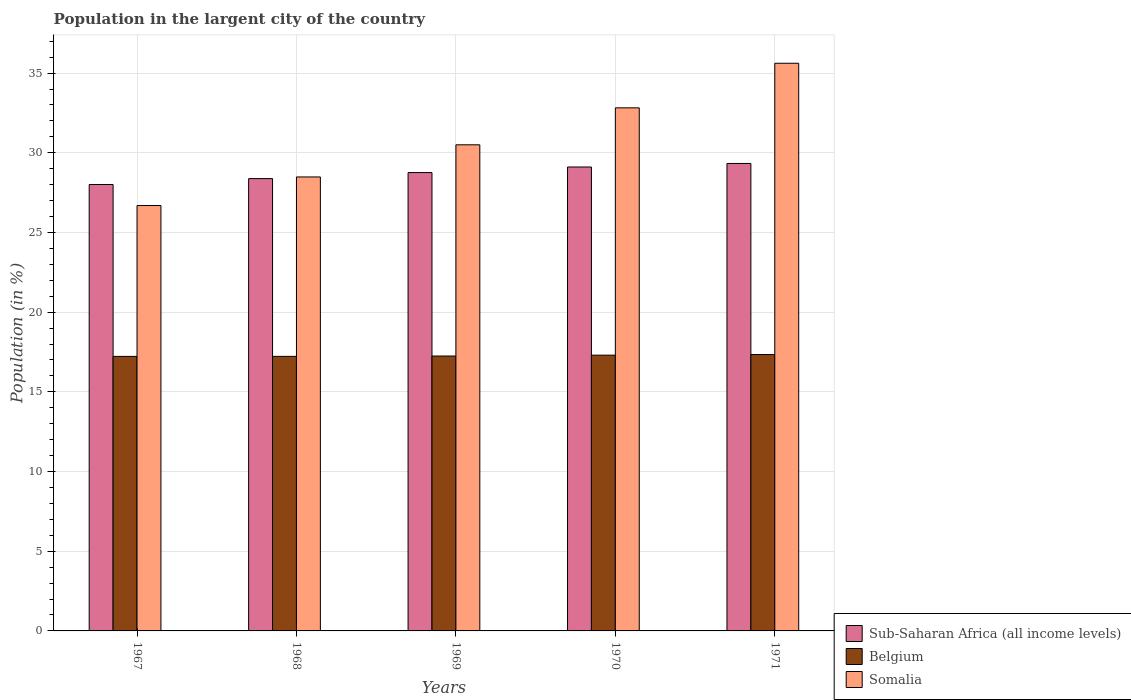How many groups of bars are there?
Offer a very short reply. 5. Are the number of bars on each tick of the X-axis equal?
Your response must be concise. Yes. What is the label of the 2nd group of bars from the left?
Your answer should be compact. 1968. In how many cases, is the number of bars for a given year not equal to the number of legend labels?
Offer a terse response. 0. What is the percentage of population in the largent city in Sub-Saharan Africa (all income levels) in 1970?
Your answer should be very brief. 29.11. Across all years, what is the maximum percentage of population in the largent city in Somalia?
Your answer should be very brief. 35.62. Across all years, what is the minimum percentage of population in the largent city in Sub-Saharan Africa (all income levels)?
Your answer should be compact. 28.01. In which year was the percentage of population in the largent city in Belgium minimum?
Provide a succinct answer. 1967. What is the total percentage of population in the largent city in Somalia in the graph?
Make the answer very short. 154.11. What is the difference between the percentage of population in the largent city in Sub-Saharan Africa (all income levels) in 1970 and that in 1971?
Provide a succinct answer. -0.22. What is the difference between the percentage of population in the largent city in Somalia in 1968 and the percentage of population in the largent city in Belgium in 1971?
Provide a short and direct response. 11.14. What is the average percentage of population in the largent city in Sub-Saharan Africa (all income levels) per year?
Give a very brief answer. 28.72. In the year 1969, what is the difference between the percentage of population in the largent city in Sub-Saharan Africa (all income levels) and percentage of population in the largent city in Belgium?
Ensure brevity in your answer.  11.51. What is the ratio of the percentage of population in the largent city in Somalia in 1968 to that in 1970?
Your answer should be very brief. 0.87. Is the percentage of population in the largent city in Sub-Saharan Africa (all income levels) in 1968 less than that in 1969?
Make the answer very short. Yes. What is the difference between the highest and the second highest percentage of population in the largent city in Somalia?
Provide a succinct answer. 2.8. What is the difference between the highest and the lowest percentage of population in the largent city in Belgium?
Your answer should be compact. 0.12. What does the 3rd bar from the left in 1967 represents?
Provide a short and direct response. Somalia. What does the 3rd bar from the right in 1967 represents?
Give a very brief answer. Sub-Saharan Africa (all income levels). Are all the bars in the graph horizontal?
Make the answer very short. No. How many years are there in the graph?
Your response must be concise. 5. What is the difference between two consecutive major ticks on the Y-axis?
Your response must be concise. 5. Are the values on the major ticks of Y-axis written in scientific E-notation?
Ensure brevity in your answer.  No. Does the graph contain any zero values?
Your answer should be compact. No. How are the legend labels stacked?
Keep it short and to the point. Vertical. What is the title of the graph?
Provide a short and direct response. Population in the largent city of the country. Does "Fiji" appear as one of the legend labels in the graph?
Give a very brief answer. No. What is the label or title of the Y-axis?
Give a very brief answer. Population (in %). What is the Population (in %) in Sub-Saharan Africa (all income levels) in 1967?
Keep it short and to the point. 28.01. What is the Population (in %) in Belgium in 1967?
Give a very brief answer. 17.22. What is the Population (in %) in Somalia in 1967?
Ensure brevity in your answer.  26.69. What is the Population (in %) in Sub-Saharan Africa (all income levels) in 1968?
Your answer should be very brief. 28.38. What is the Population (in %) of Belgium in 1968?
Offer a very short reply. 17.23. What is the Population (in %) in Somalia in 1968?
Give a very brief answer. 28.48. What is the Population (in %) of Sub-Saharan Africa (all income levels) in 1969?
Offer a very short reply. 28.76. What is the Population (in %) of Belgium in 1969?
Make the answer very short. 17.25. What is the Population (in %) in Somalia in 1969?
Offer a very short reply. 30.5. What is the Population (in %) in Sub-Saharan Africa (all income levels) in 1970?
Make the answer very short. 29.11. What is the Population (in %) in Belgium in 1970?
Your response must be concise. 17.3. What is the Population (in %) in Somalia in 1970?
Offer a terse response. 32.82. What is the Population (in %) of Sub-Saharan Africa (all income levels) in 1971?
Offer a terse response. 29.33. What is the Population (in %) in Belgium in 1971?
Provide a succinct answer. 17.34. What is the Population (in %) of Somalia in 1971?
Ensure brevity in your answer.  35.62. Across all years, what is the maximum Population (in %) of Sub-Saharan Africa (all income levels)?
Provide a short and direct response. 29.33. Across all years, what is the maximum Population (in %) of Belgium?
Your answer should be very brief. 17.34. Across all years, what is the maximum Population (in %) of Somalia?
Give a very brief answer. 35.62. Across all years, what is the minimum Population (in %) in Sub-Saharan Africa (all income levels)?
Ensure brevity in your answer.  28.01. Across all years, what is the minimum Population (in %) of Belgium?
Your answer should be very brief. 17.22. Across all years, what is the minimum Population (in %) of Somalia?
Keep it short and to the point. 26.69. What is the total Population (in %) of Sub-Saharan Africa (all income levels) in the graph?
Make the answer very short. 143.58. What is the total Population (in %) in Belgium in the graph?
Provide a succinct answer. 86.34. What is the total Population (in %) in Somalia in the graph?
Your answer should be compact. 154.11. What is the difference between the Population (in %) of Sub-Saharan Africa (all income levels) in 1967 and that in 1968?
Give a very brief answer. -0.37. What is the difference between the Population (in %) in Belgium in 1967 and that in 1968?
Offer a very short reply. -0. What is the difference between the Population (in %) in Somalia in 1967 and that in 1968?
Offer a terse response. -1.79. What is the difference between the Population (in %) of Sub-Saharan Africa (all income levels) in 1967 and that in 1969?
Your answer should be compact. -0.75. What is the difference between the Population (in %) of Belgium in 1967 and that in 1969?
Offer a very short reply. -0.02. What is the difference between the Population (in %) in Somalia in 1967 and that in 1969?
Provide a succinct answer. -3.81. What is the difference between the Population (in %) in Sub-Saharan Africa (all income levels) in 1967 and that in 1970?
Offer a terse response. -1.1. What is the difference between the Population (in %) in Belgium in 1967 and that in 1970?
Keep it short and to the point. -0.08. What is the difference between the Population (in %) in Somalia in 1967 and that in 1970?
Ensure brevity in your answer.  -6.13. What is the difference between the Population (in %) in Sub-Saharan Africa (all income levels) in 1967 and that in 1971?
Provide a short and direct response. -1.32. What is the difference between the Population (in %) of Belgium in 1967 and that in 1971?
Offer a very short reply. -0.12. What is the difference between the Population (in %) in Somalia in 1967 and that in 1971?
Provide a short and direct response. -8.93. What is the difference between the Population (in %) in Sub-Saharan Africa (all income levels) in 1968 and that in 1969?
Offer a very short reply. -0.38. What is the difference between the Population (in %) in Belgium in 1968 and that in 1969?
Make the answer very short. -0.02. What is the difference between the Population (in %) in Somalia in 1968 and that in 1969?
Your response must be concise. -2.02. What is the difference between the Population (in %) of Sub-Saharan Africa (all income levels) in 1968 and that in 1970?
Your response must be concise. -0.73. What is the difference between the Population (in %) of Belgium in 1968 and that in 1970?
Your response must be concise. -0.07. What is the difference between the Population (in %) in Somalia in 1968 and that in 1970?
Make the answer very short. -4.34. What is the difference between the Population (in %) of Sub-Saharan Africa (all income levels) in 1968 and that in 1971?
Give a very brief answer. -0.95. What is the difference between the Population (in %) of Belgium in 1968 and that in 1971?
Make the answer very short. -0.11. What is the difference between the Population (in %) of Somalia in 1968 and that in 1971?
Offer a very short reply. -7.13. What is the difference between the Population (in %) of Sub-Saharan Africa (all income levels) in 1969 and that in 1970?
Your answer should be compact. -0.35. What is the difference between the Population (in %) in Belgium in 1969 and that in 1970?
Offer a terse response. -0.05. What is the difference between the Population (in %) in Somalia in 1969 and that in 1970?
Your response must be concise. -2.32. What is the difference between the Population (in %) of Sub-Saharan Africa (all income levels) in 1969 and that in 1971?
Make the answer very short. -0.57. What is the difference between the Population (in %) in Belgium in 1969 and that in 1971?
Make the answer very short. -0.09. What is the difference between the Population (in %) in Somalia in 1969 and that in 1971?
Your answer should be very brief. -5.12. What is the difference between the Population (in %) of Sub-Saharan Africa (all income levels) in 1970 and that in 1971?
Provide a short and direct response. -0.22. What is the difference between the Population (in %) in Belgium in 1970 and that in 1971?
Provide a succinct answer. -0.04. What is the difference between the Population (in %) in Somalia in 1970 and that in 1971?
Give a very brief answer. -2.8. What is the difference between the Population (in %) in Sub-Saharan Africa (all income levels) in 1967 and the Population (in %) in Belgium in 1968?
Offer a terse response. 10.78. What is the difference between the Population (in %) in Sub-Saharan Africa (all income levels) in 1967 and the Population (in %) in Somalia in 1968?
Provide a short and direct response. -0.47. What is the difference between the Population (in %) in Belgium in 1967 and the Population (in %) in Somalia in 1968?
Give a very brief answer. -11.26. What is the difference between the Population (in %) in Sub-Saharan Africa (all income levels) in 1967 and the Population (in %) in Belgium in 1969?
Your response must be concise. 10.76. What is the difference between the Population (in %) in Sub-Saharan Africa (all income levels) in 1967 and the Population (in %) in Somalia in 1969?
Provide a succinct answer. -2.49. What is the difference between the Population (in %) of Belgium in 1967 and the Population (in %) of Somalia in 1969?
Provide a short and direct response. -13.27. What is the difference between the Population (in %) in Sub-Saharan Africa (all income levels) in 1967 and the Population (in %) in Belgium in 1970?
Ensure brevity in your answer.  10.71. What is the difference between the Population (in %) of Sub-Saharan Africa (all income levels) in 1967 and the Population (in %) of Somalia in 1970?
Give a very brief answer. -4.81. What is the difference between the Population (in %) of Belgium in 1967 and the Population (in %) of Somalia in 1970?
Offer a terse response. -15.59. What is the difference between the Population (in %) of Sub-Saharan Africa (all income levels) in 1967 and the Population (in %) of Belgium in 1971?
Offer a very short reply. 10.67. What is the difference between the Population (in %) in Sub-Saharan Africa (all income levels) in 1967 and the Population (in %) in Somalia in 1971?
Your answer should be compact. -7.61. What is the difference between the Population (in %) in Belgium in 1967 and the Population (in %) in Somalia in 1971?
Keep it short and to the point. -18.39. What is the difference between the Population (in %) in Sub-Saharan Africa (all income levels) in 1968 and the Population (in %) in Belgium in 1969?
Offer a terse response. 11.13. What is the difference between the Population (in %) of Sub-Saharan Africa (all income levels) in 1968 and the Population (in %) of Somalia in 1969?
Your response must be concise. -2.12. What is the difference between the Population (in %) in Belgium in 1968 and the Population (in %) in Somalia in 1969?
Make the answer very short. -13.27. What is the difference between the Population (in %) in Sub-Saharan Africa (all income levels) in 1968 and the Population (in %) in Belgium in 1970?
Keep it short and to the point. 11.08. What is the difference between the Population (in %) in Sub-Saharan Africa (all income levels) in 1968 and the Population (in %) in Somalia in 1970?
Ensure brevity in your answer.  -4.44. What is the difference between the Population (in %) of Belgium in 1968 and the Population (in %) of Somalia in 1970?
Provide a short and direct response. -15.59. What is the difference between the Population (in %) of Sub-Saharan Africa (all income levels) in 1968 and the Population (in %) of Belgium in 1971?
Make the answer very short. 11.04. What is the difference between the Population (in %) of Sub-Saharan Africa (all income levels) in 1968 and the Population (in %) of Somalia in 1971?
Keep it short and to the point. -7.24. What is the difference between the Population (in %) in Belgium in 1968 and the Population (in %) in Somalia in 1971?
Give a very brief answer. -18.39. What is the difference between the Population (in %) in Sub-Saharan Africa (all income levels) in 1969 and the Population (in %) in Belgium in 1970?
Ensure brevity in your answer.  11.46. What is the difference between the Population (in %) of Sub-Saharan Africa (all income levels) in 1969 and the Population (in %) of Somalia in 1970?
Offer a very short reply. -4.06. What is the difference between the Population (in %) in Belgium in 1969 and the Population (in %) in Somalia in 1970?
Offer a very short reply. -15.57. What is the difference between the Population (in %) in Sub-Saharan Africa (all income levels) in 1969 and the Population (in %) in Belgium in 1971?
Offer a very short reply. 11.42. What is the difference between the Population (in %) in Sub-Saharan Africa (all income levels) in 1969 and the Population (in %) in Somalia in 1971?
Your answer should be very brief. -6.86. What is the difference between the Population (in %) in Belgium in 1969 and the Population (in %) in Somalia in 1971?
Ensure brevity in your answer.  -18.37. What is the difference between the Population (in %) of Sub-Saharan Africa (all income levels) in 1970 and the Population (in %) of Belgium in 1971?
Make the answer very short. 11.77. What is the difference between the Population (in %) in Sub-Saharan Africa (all income levels) in 1970 and the Population (in %) in Somalia in 1971?
Offer a very short reply. -6.51. What is the difference between the Population (in %) of Belgium in 1970 and the Population (in %) of Somalia in 1971?
Keep it short and to the point. -18.31. What is the average Population (in %) in Sub-Saharan Africa (all income levels) per year?
Give a very brief answer. 28.72. What is the average Population (in %) of Belgium per year?
Give a very brief answer. 17.27. What is the average Population (in %) of Somalia per year?
Offer a terse response. 30.82. In the year 1967, what is the difference between the Population (in %) in Sub-Saharan Africa (all income levels) and Population (in %) in Belgium?
Offer a terse response. 10.78. In the year 1967, what is the difference between the Population (in %) in Sub-Saharan Africa (all income levels) and Population (in %) in Somalia?
Ensure brevity in your answer.  1.32. In the year 1967, what is the difference between the Population (in %) of Belgium and Population (in %) of Somalia?
Give a very brief answer. -9.47. In the year 1968, what is the difference between the Population (in %) of Sub-Saharan Africa (all income levels) and Population (in %) of Belgium?
Give a very brief answer. 11.15. In the year 1968, what is the difference between the Population (in %) in Sub-Saharan Africa (all income levels) and Population (in %) in Somalia?
Provide a short and direct response. -0.1. In the year 1968, what is the difference between the Population (in %) of Belgium and Population (in %) of Somalia?
Keep it short and to the point. -11.26. In the year 1969, what is the difference between the Population (in %) in Sub-Saharan Africa (all income levels) and Population (in %) in Belgium?
Your response must be concise. 11.51. In the year 1969, what is the difference between the Population (in %) of Sub-Saharan Africa (all income levels) and Population (in %) of Somalia?
Make the answer very short. -1.74. In the year 1969, what is the difference between the Population (in %) in Belgium and Population (in %) in Somalia?
Offer a terse response. -13.25. In the year 1970, what is the difference between the Population (in %) of Sub-Saharan Africa (all income levels) and Population (in %) of Belgium?
Your answer should be compact. 11.81. In the year 1970, what is the difference between the Population (in %) of Sub-Saharan Africa (all income levels) and Population (in %) of Somalia?
Provide a succinct answer. -3.71. In the year 1970, what is the difference between the Population (in %) of Belgium and Population (in %) of Somalia?
Ensure brevity in your answer.  -15.52. In the year 1971, what is the difference between the Population (in %) in Sub-Saharan Africa (all income levels) and Population (in %) in Belgium?
Ensure brevity in your answer.  11.99. In the year 1971, what is the difference between the Population (in %) of Sub-Saharan Africa (all income levels) and Population (in %) of Somalia?
Keep it short and to the point. -6.29. In the year 1971, what is the difference between the Population (in %) of Belgium and Population (in %) of Somalia?
Offer a terse response. -18.28. What is the ratio of the Population (in %) in Sub-Saharan Africa (all income levels) in 1967 to that in 1968?
Offer a terse response. 0.99. What is the ratio of the Population (in %) of Belgium in 1967 to that in 1968?
Provide a succinct answer. 1. What is the ratio of the Population (in %) of Somalia in 1967 to that in 1968?
Ensure brevity in your answer.  0.94. What is the ratio of the Population (in %) of Sub-Saharan Africa (all income levels) in 1967 to that in 1969?
Provide a short and direct response. 0.97. What is the ratio of the Population (in %) in Somalia in 1967 to that in 1969?
Make the answer very short. 0.88. What is the ratio of the Population (in %) in Sub-Saharan Africa (all income levels) in 1967 to that in 1970?
Your answer should be compact. 0.96. What is the ratio of the Population (in %) in Belgium in 1967 to that in 1970?
Your answer should be compact. 1. What is the ratio of the Population (in %) of Somalia in 1967 to that in 1970?
Provide a short and direct response. 0.81. What is the ratio of the Population (in %) in Sub-Saharan Africa (all income levels) in 1967 to that in 1971?
Keep it short and to the point. 0.95. What is the ratio of the Population (in %) in Somalia in 1967 to that in 1971?
Your answer should be very brief. 0.75. What is the ratio of the Population (in %) in Somalia in 1968 to that in 1969?
Give a very brief answer. 0.93. What is the ratio of the Population (in %) of Belgium in 1968 to that in 1970?
Offer a very short reply. 1. What is the ratio of the Population (in %) in Somalia in 1968 to that in 1970?
Your answer should be compact. 0.87. What is the ratio of the Population (in %) of Sub-Saharan Africa (all income levels) in 1968 to that in 1971?
Ensure brevity in your answer.  0.97. What is the ratio of the Population (in %) of Somalia in 1968 to that in 1971?
Give a very brief answer. 0.8. What is the ratio of the Population (in %) of Somalia in 1969 to that in 1970?
Offer a terse response. 0.93. What is the ratio of the Population (in %) in Sub-Saharan Africa (all income levels) in 1969 to that in 1971?
Your response must be concise. 0.98. What is the ratio of the Population (in %) of Somalia in 1969 to that in 1971?
Offer a terse response. 0.86. What is the ratio of the Population (in %) in Sub-Saharan Africa (all income levels) in 1970 to that in 1971?
Provide a short and direct response. 0.99. What is the ratio of the Population (in %) in Belgium in 1970 to that in 1971?
Offer a terse response. 1. What is the ratio of the Population (in %) in Somalia in 1970 to that in 1971?
Make the answer very short. 0.92. What is the difference between the highest and the second highest Population (in %) of Sub-Saharan Africa (all income levels)?
Provide a succinct answer. 0.22. What is the difference between the highest and the second highest Population (in %) of Belgium?
Keep it short and to the point. 0.04. What is the difference between the highest and the second highest Population (in %) of Somalia?
Give a very brief answer. 2.8. What is the difference between the highest and the lowest Population (in %) of Sub-Saharan Africa (all income levels)?
Keep it short and to the point. 1.32. What is the difference between the highest and the lowest Population (in %) in Belgium?
Your response must be concise. 0.12. What is the difference between the highest and the lowest Population (in %) of Somalia?
Keep it short and to the point. 8.93. 